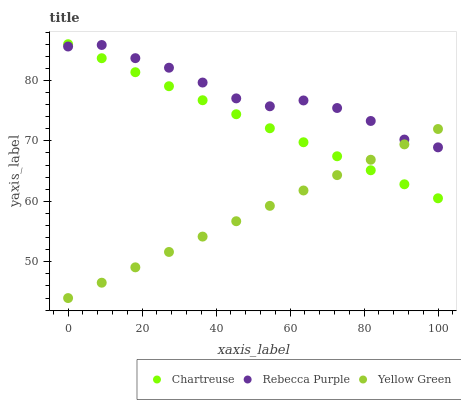Does Yellow Green have the minimum area under the curve?
Answer yes or no. Yes. Does Rebecca Purple have the maximum area under the curve?
Answer yes or no. Yes. Does Rebecca Purple have the minimum area under the curve?
Answer yes or no. No. Does Yellow Green have the maximum area under the curve?
Answer yes or no. No. Is Yellow Green the smoothest?
Answer yes or no. Yes. Is Rebecca Purple the roughest?
Answer yes or no. Yes. Is Rebecca Purple the smoothest?
Answer yes or no. No. Is Yellow Green the roughest?
Answer yes or no. No. Does Yellow Green have the lowest value?
Answer yes or no. Yes. Does Rebecca Purple have the lowest value?
Answer yes or no. No. Does Chartreuse have the highest value?
Answer yes or no. Yes. Does Rebecca Purple have the highest value?
Answer yes or no. No. Does Yellow Green intersect Rebecca Purple?
Answer yes or no. Yes. Is Yellow Green less than Rebecca Purple?
Answer yes or no. No. Is Yellow Green greater than Rebecca Purple?
Answer yes or no. No. 